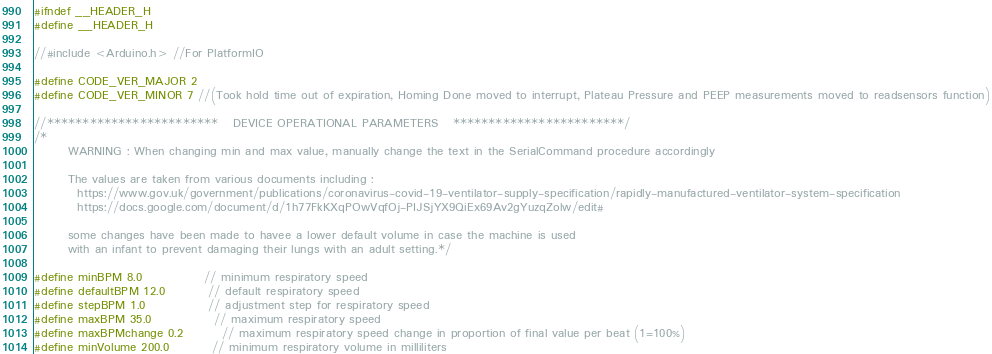<code> <loc_0><loc_0><loc_500><loc_500><_C_>#ifndef __HEADER_H
#define __HEADER_H

//#include <Arduino.h> //For PlatformIO

#define CODE_VER_MAJOR 2
#define CODE_VER_MINOR 7 //(Took hold time out of expiration, Homing Done moved to interrupt, Plateau Pressure and PEEP measurements moved to readsensors function)

//************************   DEVICE OPERATIONAL PARAMETERS   ************************/
/*
       WARNING : When changing min and max value, manually change the text in the SerialCommand procedure accordingly

       The values are taken from various documents including :
         https://www.gov.uk/government/publications/coronavirus-covid-19-ventilator-supply-specification/rapidly-manufactured-ventilator-system-specification
         https://docs.google.com/document/d/1h77FkKXqPOwVqfOj-PIJSjYX9QiEx69Av2gYuzqZolw/edit#

       some changes have been made to havee a lower default volume in case the machine is used
       with an infant to prevent damaging their lungs with an adult setting.*/

#define minBPM 8.0             // minimum respiratory speed
#define defaultBPM 12.0         // default respiratory speed
#define stepBPM 1.0             // adjustment step for respiratory speed
#define maxBPM 35.0             // maximum respiratory speed
#define maxBPMchange 0.2        // maximum respiratory speed change in proportion of final value per beat (1=100%)
#define minVolume 200.0         // minimum respiratory volume in milliliters</code> 